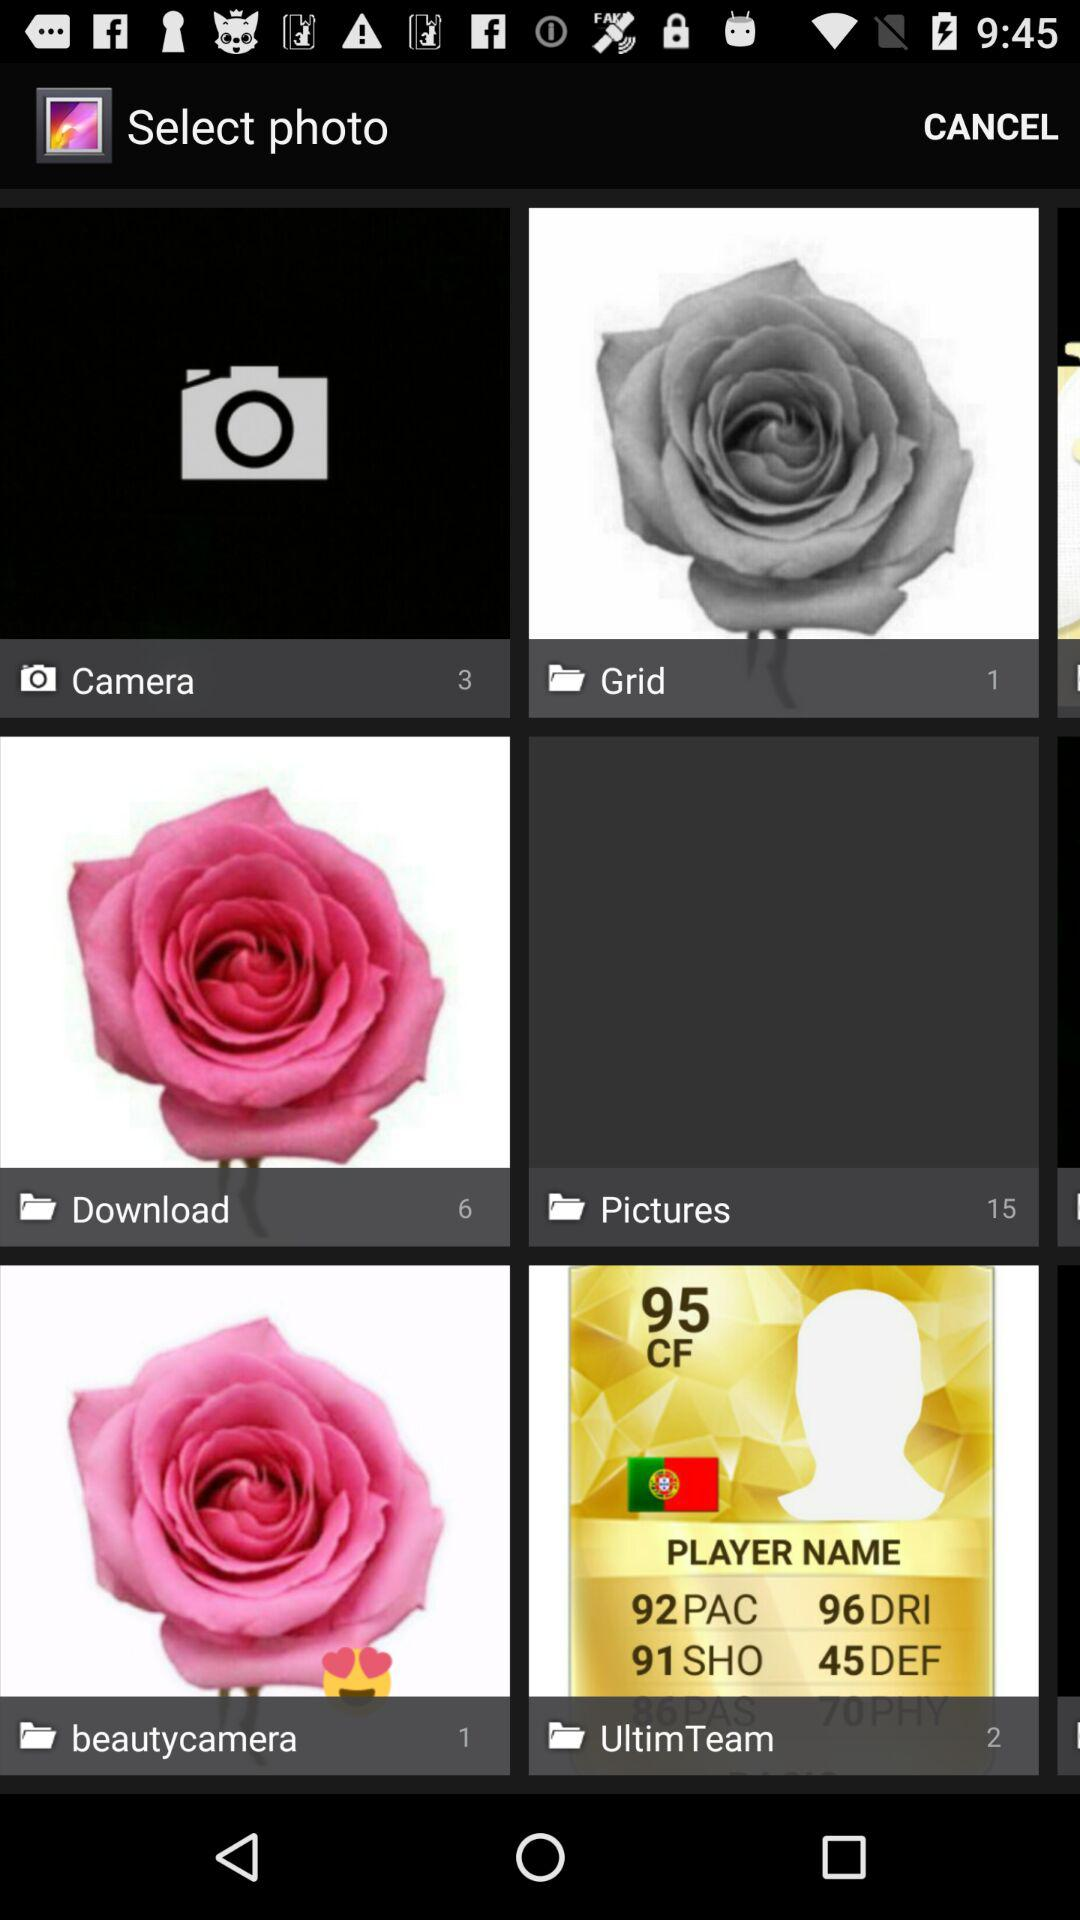Which folder has six images? The folder "Download" has six images. 